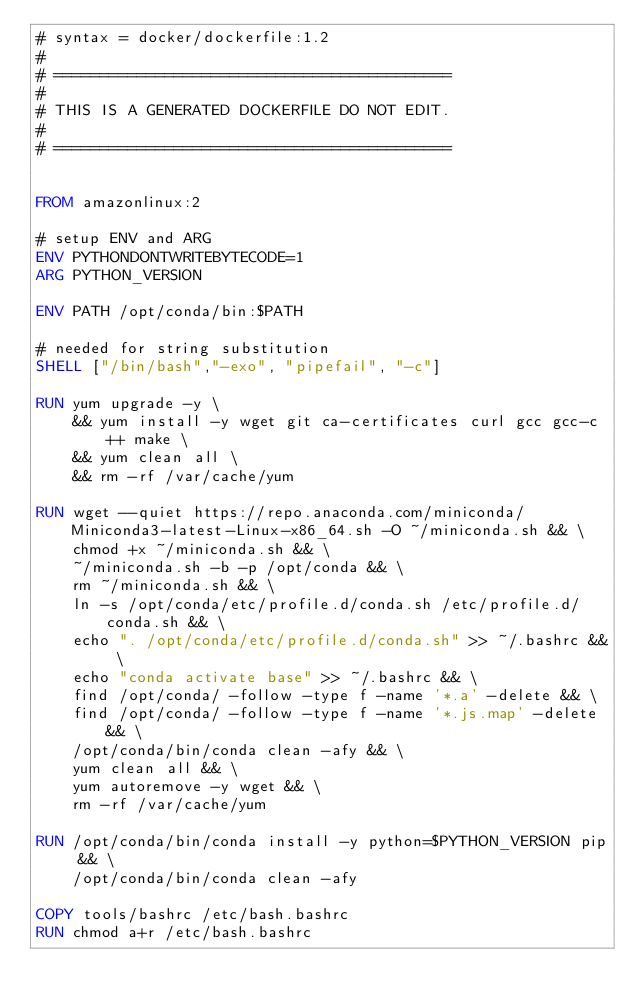Convert code to text. <code><loc_0><loc_0><loc_500><loc_500><_Dockerfile_># syntax = docker/dockerfile:1.2
#
# ===========================================
#
# THIS IS A GENERATED DOCKERFILE DO NOT EDIT.
#
# ===========================================


FROM amazonlinux:2

# setup ENV and ARG
ENV PYTHONDONTWRITEBYTECODE=1
ARG PYTHON_VERSION

ENV PATH /opt/conda/bin:$PATH

# needed for string substitution
SHELL ["/bin/bash","-exo", "pipefail", "-c"]

RUN yum upgrade -y \
    && yum install -y wget git ca-certificates curl gcc gcc-c++ make \
    && yum clean all \
    && rm -rf /var/cache/yum

RUN wget --quiet https://repo.anaconda.com/miniconda/Miniconda3-latest-Linux-x86_64.sh -O ~/miniconda.sh && \
    chmod +x ~/miniconda.sh && \
    ~/miniconda.sh -b -p /opt/conda && \
    rm ~/miniconda.sh && \
    ln -s /opt/conda/etc/profile.d/conda.sh /etc/profile.d/conda.sh && \
    echo ". /opt/conda/etc/profile.d/conda.sh" >> ~/.bashrc && \
    echo "conda activate base" >> ~/.bashrc && \
    find /opt/conda/ -follow -type f -name '*.a' -delete && \
    find /opt/conda/ -follow -type f -name '*.js.map' -delete && \
    /opt/conda/bin/conda clean -afy && \
    yum clean all && \
    yum autoremove -y wget && \
    rm -rf /var/cache/yum

RUN /opt/conda/bin/conda install -y python=$PYTHON_VERSION pip && \
    /opt/conda/bin/conda clean -afy

COPY tools/bashrc /etc/bash.bashrc
RUN chmod a+r /etc/bash.bashrc</code> 